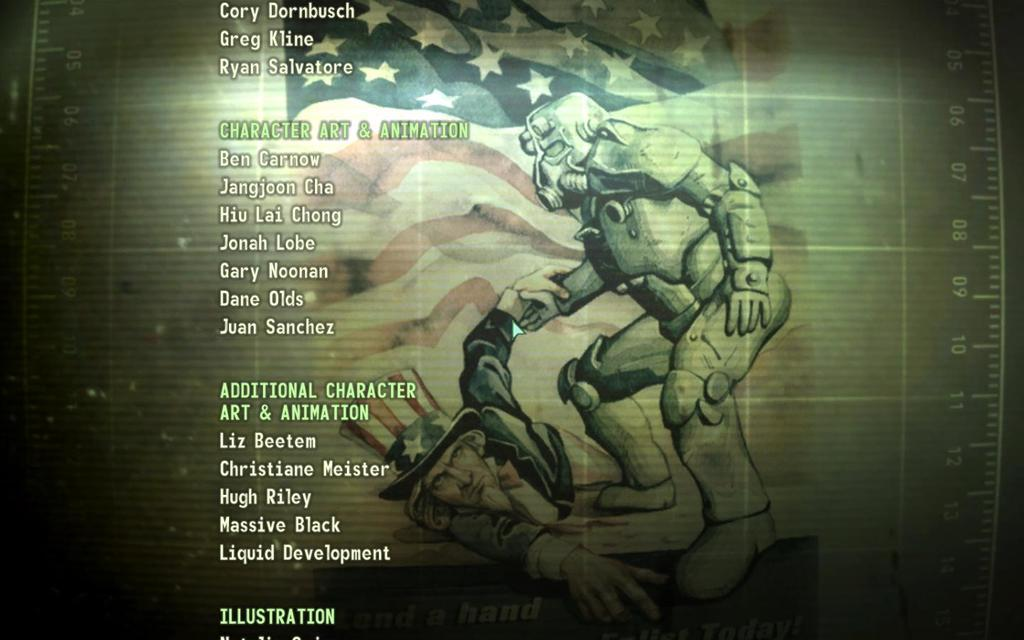<image>
Present a compact description of the photo's key features. Ben Carnow provided some character art and animation for the video game. 